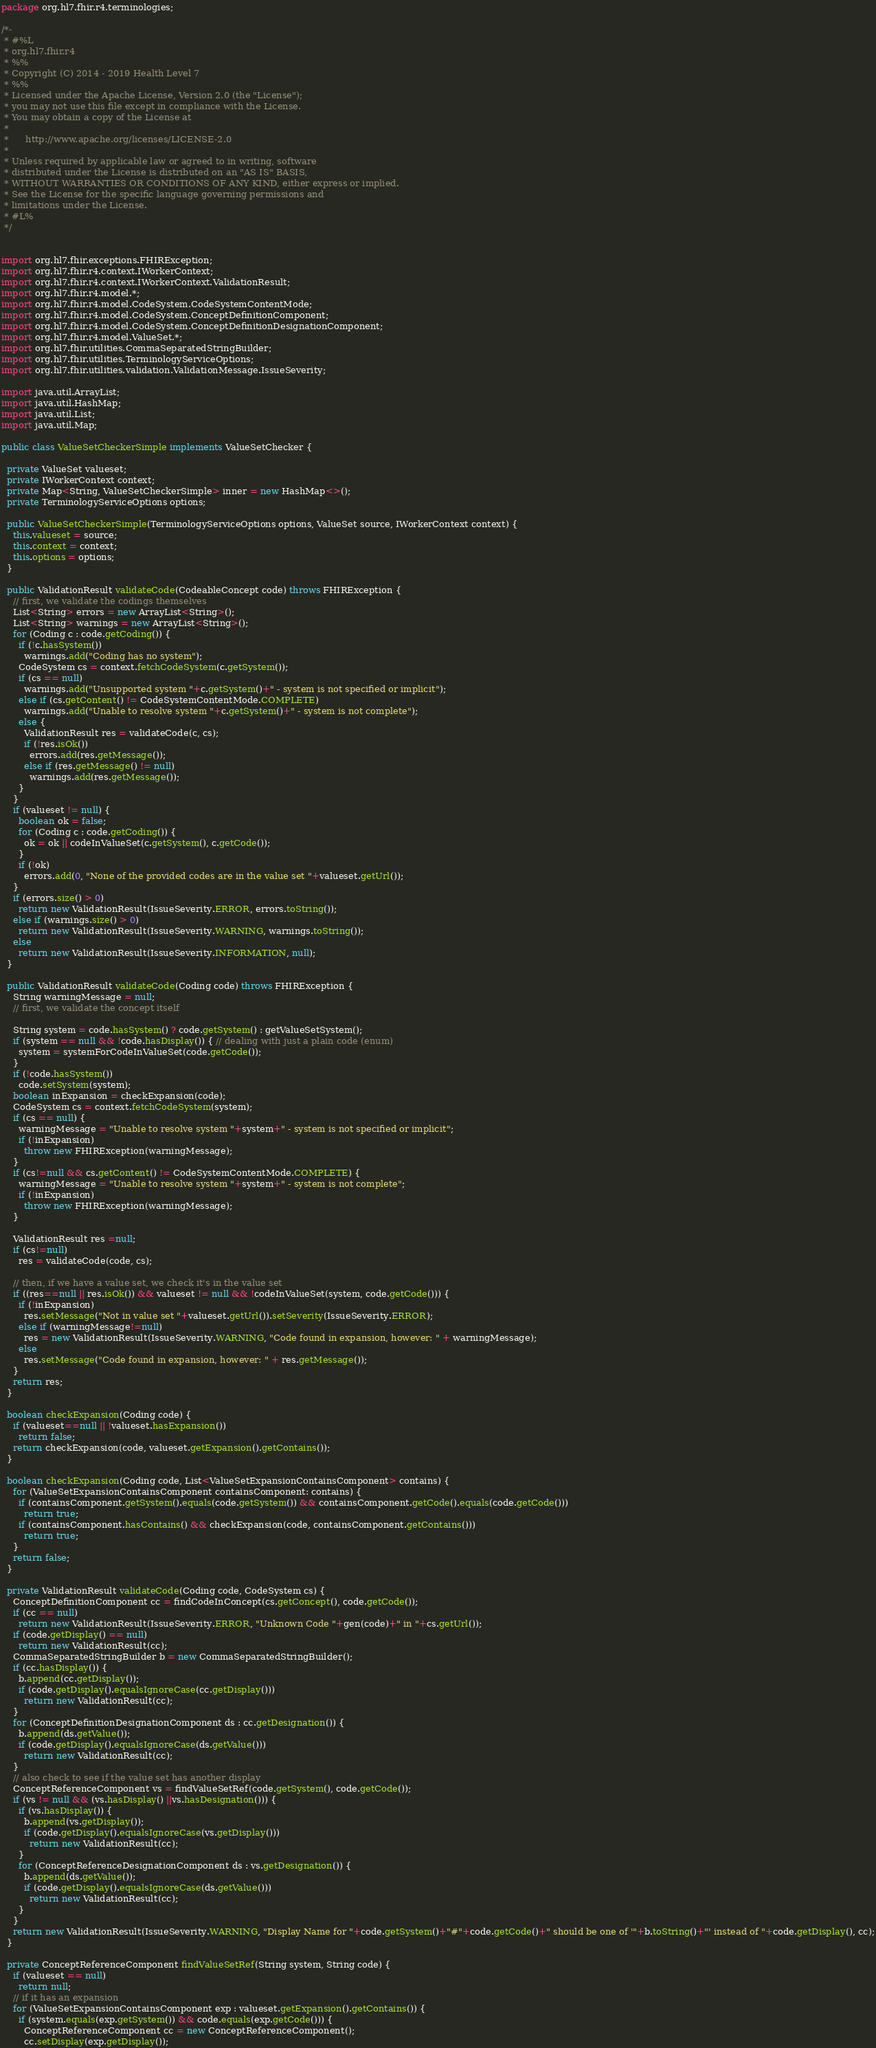Convert code to text. <code><loc_0><loc_0><loc_500><loc_500><_Java_>package org.hl7.fhir.r4.terminologies;

/*-
 * #%L
 * org.hl7.fhir.r4
 * %%
 * Copyright (C) 2014 - 2019 Health Level 7
 * %%
 * Licensed under the Apache License, Version 2.0 (the "License");
 * you may not use this file except in compliance with the License.
 * You may obtain a copy of the License at
 * 
 *      http://www.apache.org/licenses/LICENSE-2.0
 * 
 * Unless required by applicable law or agreed to in writing, software
 * distributed under the License is distributed on an "AS IS" BASIS,
 * WITHOUT WARRANTIES OR CONDITIONS OF ANY KIND, either express or implied.
 * See the License for the specific language governing permissions and
 * limitations under the License.
 * #L%
 */


import org.hl7.fhir.exceptions.FHIRException;
import org.hl7.fhir.r4.context.IWorkerContext;
import org.hl7.fhir.r4.context.IWorkerContext.ValidationResult;
import org.hl7.fhir.r4.model.*;
import org.hl7.fhir.r4.model.CodeSystem.CodeSystemContentMode;
import org.hl7.fhir.r4.model.CodeSystem.ConceptDefinitionComponent;
import org.hl7.fhir.r4.model.CodeSystem.ConceptDefinitionDesignationComponent;
import org.hl7.fhir.r4.model.ValueSet.*;
import org.hl7.fhir.utilities.CommaSeparatedStringBuilder;
import org.hl7.fhir.utilities.TerminologyServiceOptions;
import org.hl7.fhir.utilities.validation.ValidationMessage.IssueSeverity;

import java.util.ArrayList;
import java.util.HashMap;
import java.util.List;
import java.util.Map;

public class ValueSetCheckerSimple implements ValueSetChecker {

  private ValueSet valueset;
  private IWorkerContext context;
  private Map<String, ValueSetCheckerSimple> inner = new HashMap<>();
  private TerminologyServiceOptions options;

  public ValueSetCheckerSimple(TerminologyServiceOptions options, ValueSet source, IWorkerContext context) {
    this.valueset = source;
    this.context = context;
    this.options = options;
  }

  public ValidationResult validateCode(CodeableConcept code) throws FHIRException {
    // first, we validate the codings themselves
    List<String> errors = new ArrayList<String>();
    List<String> warnings = new ArrayList<String>();
    for (Coding c : code.getCoding()) {
      if (!c.hasSystem())
        warnings.add("Coding has no system");
      CodeSystem cs = context.fetchCodeSystem(c.getSystem());
      if (cs == null)
        warnings.add("Unsupported system "+c.getSystem()+" - system is not specified or implicit");
      else if (cs.getContent() != CodeSystemContentMode.COMPLETE)
        warnings.add("Unable to resolve system "+c.getSystem()+" - system is not complete");
      else {
        ValidationResult res = validateCode(c, cs);
        if (!res.isOk())
          errors.add(res.getMessage());
        else if (res.getMessage() != null)
          warnings.add(res.getMessage());
      }
    }
    if (valueset != null) {
      boolean ok = false;
      for (Coding c : code.getCoding()) {
        ok = ok || codeInValueSet(c.getSystem(), c.getCode());
      }
      if (!ok)
        errors.add(0, "None of the provided codes are in the value set "+valueset.getUrl());
    }
    if (errors.size() > 0)
      return new ValidationResult(IssueSeverity.ERROR, errors.toString());
    else if (warnings.size() > 0)
      return new ValidationResult(IssueSeverity.WARNING, warnings.toString());
    else 
      return new ValidationResult(IssueSeverity.INFORMATION, null);
  }

  public ValidationResult validateCode(Coding code) throws FHIRException {
    String warningMessage = null;
    // first, we validate the concept itself
    
    String system = code.hasSystem() ? code.getSystem() : getValueSetSystem();
    if (system == null && !code.hasDisplay()) { // dealing with just a plain code (enum)
      system = systemForCodeInValueSet(code.getCode());
    }
    if (!code.hasSystem())
      code.setSystem(system);
    boolean inExpansion = checkExpansion(code);
    CodeSystem cs = context.fetchCodeSystem(system);
    if (cs == null) {
      warningMessage = "Unable to resolve system "+system+" - system is not specified or implicit";
      if (!inExpansion)
        throw new FHIRException(warningMessage);
    }
    if (cs!=null && cs.getContent() != CodeSystemContentMode.COMPLETE) {
      warningMessage = "Unable to resolve system "+system+" - system is not complete";
      if (!inExpansion)
        throw new FHIRException(warningMessage);
    }
    
    ValidationResult res =null;
    if (cs!=null)
      res = validateCode(code, cs);
      
    // then, if we have a value set, we check it's in the value set
    if ((res==null || res.isOk()) && valueset != null && !codeInValueSet(system, code.getCode())) {
      if (!inExpansion)
        res.setMessage("Not in value set "+valueset.getUrl()).setSeverity(IssueSeverity.ERROR);
      else if (warningMessage!=null)
        res = new ValidationResult(IssueSeverity.WARNING, "Code found in expansion, however: " + warningMessage);
      else
        res.setMessage("Code found in expansion, however: " + res.getMessage());
    }
    return res;
  }

  boolean checkExpansion(Coding code) {
    if (valueset==null || !valueset.hasExpansion())
      return false;
    return checkExpansion(code, valueset.getExpansion().getContains());
  }

  boolean checkExpansion(Coding code, List<ValueSetExpansionContainsComponent> contains) {
    for (ValueSetExpansionContainsComponent containsComponent: contains) {
      if (containsComponent.getSystem().equals(code.getSystem()) && containsComponent.getCode().equals(code.getCode()))
        return true;
      if (containsComponent.hasContains() && checkExpansion(code, containsComponent.getContains()))
        return true;
    }
    return false;
  }

  private ValidationResult validateCode(Coding code, CodeSystem cs) {
    ConceptDefinitionComponent cc = findCodeInConcept(cs.getConcept(), code.getCode());
    if (cc == null)
      return new ValidationResult(IssueSeverity.ERROR, "Unknown Code "+gen(code)+" in "+cs.getUrl());
    if (code.getDisplay() == null)
      return new ValidationResult(cc);
    CommaSeparatedStringBuilder b = new CommaSeparatedStringBuilder();
    if (cc.hasDisplay()) {
      b.append(cc.getDisplay());
      if (code.getDisplay().equalsIgnoreCase(cc.getDisplay()))
        return new ValidationResult(cc);
    }
    for (ConceptDefinitionDesignationComponent ds : cc.getDesignation()) {
      b.append(ds.getValue());
      if (code.getDisplay().equalsIgnoreCase(ds.getValue()))
        return new ValidationResult(cc);
    }
    // also check to see if the value set has another display
    ConceptReferenceComponent vs = findValueSetRef(code.getSystem(), code.getCode());
    if (vs != null && (vs.hasDisplay() ||vs.hasDesignation())) {
      if (vs.hasDisplay()) {
        b.append(vs.getDisplay());
        if (code.getDisplay().equalsIgnoreCase(vs.getDisplay()))
          return new ValidationResult(cc);
      }
      for (ConceptReferenceDesignationComponent ds : vs.getDesignation()) {
        b.append(ds.getValue());
        if (code.getDisplay().equalsIgnoreCase(ds.getValue()))
          return new ValidationResult(cc);
      }
    }
    return new ValidationResult(IssueSeverity.WARNING, "Display Name for "+code.getSystem()+"#"+code.getCode()+" should be one of '"+b.toString()+"' instead of "+code.getDisplay(), cc);
  }

  private ConceptReferenceComponent findValueSetRef(String system, String code) {
    if (valueset == null)
      return null;
    // if it has an expansion
    for (ValueSetExpansionContainsComponent exp : valueset.getExpansion().getContains()) {
      if (system.equals(exp.getSystem()) && code.equals(exp.getCode())) {
        ConceptReferenceComponent cc = new ConceptReferenceComponent();
        cc.setDisplay(exp.getDisplay());</code> 